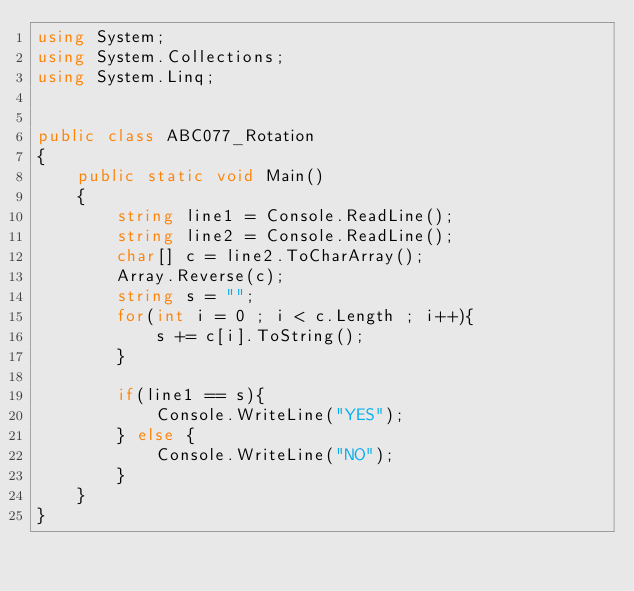<code> <loc_0><loc_0><loc_500><loc_500><_C#_>using System;
using System.Collections;
using System.Linq;


public class ABC077_Rotation
{
	public static void Main()
	{
		string line1 = Console.ReadLine();
        string line2 = Console.ReadLine();
        char[] c = line2.ToCharArray();
        Array.Reverse(c);
        string s = "";
        for(int i = 0 ; i < c.Length ; i++){
            s += c[i].ToString();
        }

        if(line1 == s){
            Console.WriteLine("YES");
        } else {
            Console.WriteLine("NO");
        }
	}
}</code> 